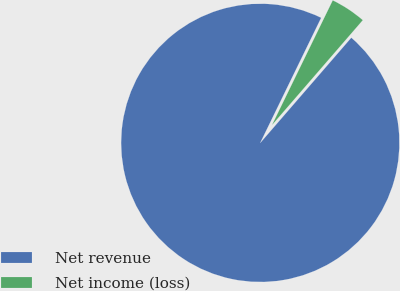Convert chart. <chart><loc_0><loc_0><loc_500><loc_500><pie_chart><fcel>Net revenue<fcel>Net income (loss)<nl><fcel>95.86%<fcel>4.14%<nl></chart> 